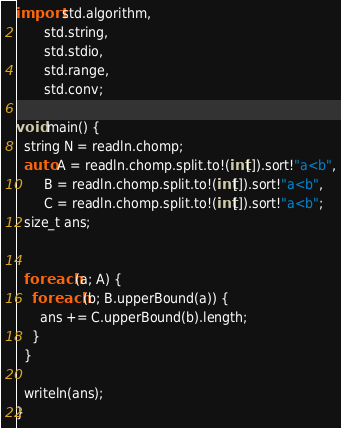<code> <loc_0><loc_0><loc_500><loc_500><_D_>import std.algorithm,
       std.string,
       std.stdio,
       std.range,
       std.conv;

void main() {
  string N = readln.chomp;
  auto A = readln.chomp.split.to!(int[]).sort!"a<b",
       B = readln.chomp.split.to!(int[]).sort!"a<b",
       C = readln.chomp.split.to!(int[]).sort!"a<b";
  size_t ans;


  foreach (a; A) {
    foreach (b; B.upperBound(a)) {
      ans += C.upperBound(b).length;
    }
  }

  writeln(ans);
}
</code> 